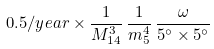<formula> <loc_0><loc_0><loc_500><loc_500>0 . 5 / y e a r \times \frac { 1 } { M _ { 1 4 } ^ { 3 } } \, \frac { 1 } { m _ { 5 } ^ { 4 } } \, \frac { \omega } { 5 ^ { \circ } \times 5 ^ { \circ } }</formula> 